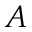Convert formula to latex. <formula><loc_0><loc_0><loc_500><loc_500>A</formula> 